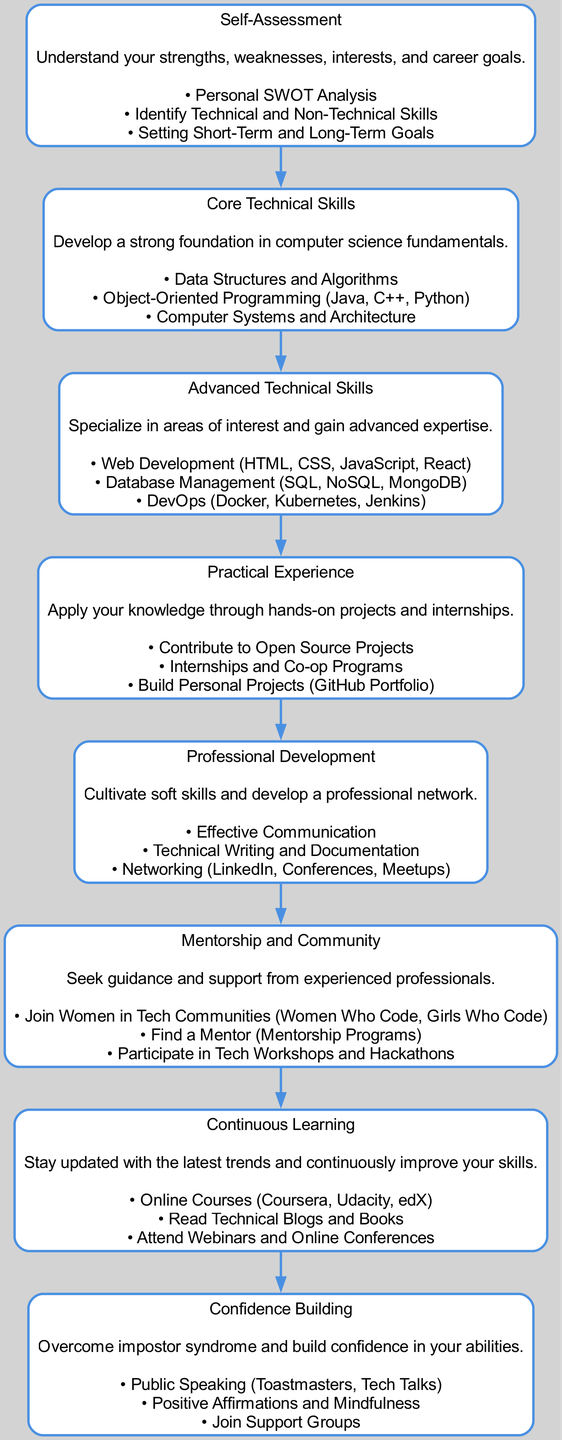What is the title of the first block? The title of the first block is derived from the data structure where it states "Self-Assessment" as the first element in the "blocks" array.
Answer: Self-Assessment How many blocks are present in the diagram? By counting the number of entries in the "blocks" list, which contains 8 individual blocks detailing various steps in the skill development roadmap.
Answer: 8 What is the description of the block titled "Continuous Learning"? The description is found from the block's "description" field, which specifies that it is about staying updated with the latest trends and continuously improving skills.
Answer: Stay updated with the latest trends and continuously improve your skills Which block focuses on building professional networks? To determine the focus of each block, we look at the description of "Professional Development," which explicitly mentions networking as a key aspect.
Answer: Professional Development What is the content related to "Confidence Building"? The content can be found under the "content" field of the "Confidence Building" block, which lists public speaking, positive affirmations, and joining support groups.
Answer: Public Speaking, Positive Affirmations, Join Support Groups Which step comes directly after "Advanced Technical Skills"? The edges of the block diagram indicate the flow from one block to the next, which shows that "Practical Experience" directly follows "Advanced Technical Skills."
Answer: Practical Experience What are the two main components of the first step? Referring to the content of the "Self-Assessment" block, the two components are identified as "Personal SWOT Analysis" and "Identify Technical and Non-Technical Skills."
Answer: Personal SWOT Analysis, Identify Technical and Non-Technical Skills What type of skills does the block titled "Core Technical Skills" emphasize? The block specifically emphasizes foundational computer science skills such as data structures and algorithms, object-oriented programming, and computer systems.
Answer: Foundation in computer science fundamentals Which block would you go to for learning about web development? By navigating through the titles, "Advanced Technical Skills" includes web development topics such as HTML, CSS, JavaScript, and React, making it the relevant block.
Answer: Advanced Technical Skills 